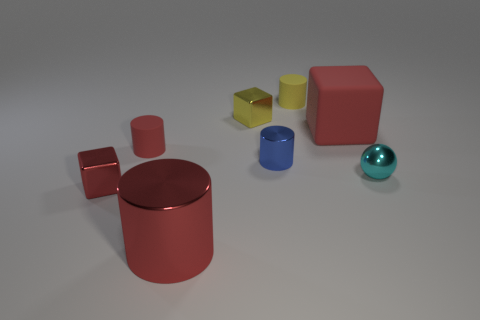There is a red shiny object that is the same size as the blue object; what is its shape?
Provide a succinct answer. Cube. What material is the small red cube?
Provide a succinct answer. Metal. What is the size of the red block to the right of the matte cylinder behind the red rubber thing in front of the large red rubber block?
Keep it short and to the point. Large. What material is the small cylinder that is the same color as the large rubber cube?
Provide a succinct answer. Rubber. How many matte objects are yellow cylinders or tiny blue objects?
Offer a very short reply. 1. What size is the cyan sphere?
Give a very brief answer. Small. How many objects are big gray metal blocks or red blocks in front of the blue cylinder?
Make the answer very short. 1. What number of other things are the same color as the big matte block?
Your answer should be compact. 3. Does the blue cylinder have the same size as the metallic object that is behind the large rubber block?
Keep it short and to the point. Yes. Is the size of the cylinder to the right of the blue object the same as the red rubber cylinder?
Your response must be concise. Yes. 